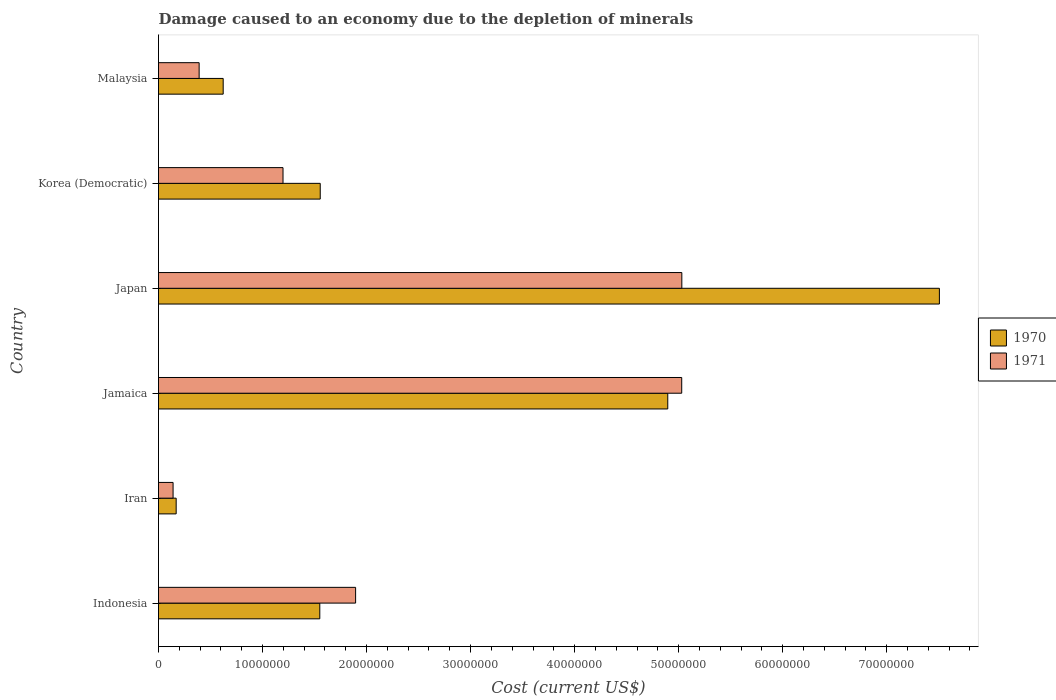How many different coloured bars are there?
Ensure brevity in your answer.  2. How many bars are there on the 4th tick from the top?
Your response must be concise. 2. What is the label of the 3rd group of bars from the top?
Offer a very short reply. Japan. What is the cost of damage caused due to the depletion of minerals in 1970 in Japan?
Your answer should be very brief. 7.51e+07. Across all countries, what is the maximum cost of damage caused due to the depletion of minerals in 1970?
Provide a succinct answer. 7.51e+07. Across all countries, what is the minimum cost of damage caused due to the depletion of minerals in 1970?
Offer a terse response. 1.70e+06. In which country was the cost of damage caused due to the depletion of minerals in 1971 minimum?
Your response must be concise. Iran. What is the total cost of damage caused due to the depletion of minerals in 1970 in the graph?
Your answer should be compact. 1.63e+08. What is the difference between the cost of damage caused due to the depletion of minerals in 1971 in Japan and that in Malaysia?
Provide a short and direct response. 4.64e+07. What is the difference between the cost of damage caused due to the depletion of minerals in 1971 in Iran and the cost of damage caused due to the depletion of minerals in 1970 in Korea (Democratic)?
Your answer should be very brief. -1.41e+07. What is the average cost of damage caused due to the depletion of minerals in 1971 per country?
Give a very brief answer. 2.28e+07. What is the difference between the cost of damage caused due to the depletion of minerals in 1970 and cost of damage caused due to the depletion of minerals in 1971 in Korea (Democratic)?
Give a very brief answer. 3.58e+06. What is the ratio of the cost of damage caused due to the depletion of minerals in 1970 in Japan to that in Korea (Democratic)?
Offer a very short reply. 4.83. Is the cost of damage caused due to the depletion of minerals in 1971 in Iran less than that in Jamaica?
Give a very brief answer. Yes. What is the difference between the highest and the second highest cost of damage caused due to the depletion of minerals in 1970?
Your response must be concise. 2.61e+07. What is the difference between the highest and the lowest cost of damage caused due to the depletion of minerals in 1971?
Offer a very short reply. 4.89e+07. In how many countries, is the cost of damage caused due to the depletion of minerals in 1971 greater than the average cost of damage caused due to the depletion of minerals in 1971 taken over all countries?
Provide a succinct answer. 2. Is the sum of the cost of damage caused due to the depletion of minerals in 1971 in Iran and Malaysia greater than the maximum cost of damage caused due to the depletion of minerals in 1970 across all countries?
Keep it short and to the point. No. What does the 1st bar from the top in Japan represents?
Your response must be concise. 1971. How many bars are there?
Your answer should be very brief. 12. Does the graph contain any zero values?
Make the answer very short. No. Where does the legend appear in the graph?
Offer a very short reply. Center right. How are the legend labels stacked?
Give a very brief answer. Vertical. What is the title of the graph?
Offer a terse response. Damage caused to an economy due to the depletion of minerals. Does "2007" appear as one of the legend labels in the graph?
Provide a short and direct response. No. What is the label or title of the X-axis?
Ensure brevity in your answer.  Cost (current US$). What is the label or title of the Y-axis?
Provide a short and direct response. Country. What is the Cost (current US$) in 1970 in Indonesia?
Your answer should be very brief. 1.55e+07. What is the Cost (current US$) in 1971 in Indonesia?
Offer a very short reply. 1.89e+07. What is the Cost (current US$) in 1970 in Iran?
Make the answer very short. 1.70e+06. What is the Cost (current US$) in 1971 in Iran?
Keep it short and to the point. 1.40e+06. What is the Cost (current US$) in 1970 in Jamaica?
Ensure brevity in your answer.  4.90e+07. What is the Cost (current US$) in 1971 in Jamaica?
Give a very brief answer. 5.03e+07. What is the Cost (current US$) of 1970 in Japan?
Your answer should be compact. 7.51e+07. What is the Cost (current US$) of 1971 in Japan?
Keep it short and to the point. 5.03e+07. What is the Cost (current US$) of 1970 in Korea (Democratic)?
Provide a succinct answer. 1.55e+07. What is the Cost (current US$) of 1971 in Korea (Democratic)?
Your answer should be compact. 1.20e+07. What is the Cost (current US$) of 1970 in Malaysia?
Offer a very short reply. 6.22e+06. What is the Cost (current US$) of 1971 in Malaysia?
Make the answer very short. 3.90e+06. Across all countries, what is the maximum Cost (current US$) in 1970?
Your response must be concise. 7.51e+07. Across all countries, what is the maximum Cost (current US$) of 1971?
Your answer should be compact. 5.03e+07. Across all countries, what is the minimum Cost (current US$) of 1970?
Your response must be concise. 1.70e+06. Across all countries, what is the minimum Cost (current US$) in 1971?
Ensure brevity in your answer.  1.40e+06. What is the total Cost (current US$) in 1970 in the graph?
Offer a very short reply. 1.63e+08. What is the total Cost (current US$) in 1971 in the graph?
Your response must be concise. 1.37e+08. What is the difference between the Cost (current US$) in 1970 in Indonesia and that in Iran?
Ensure brevity in your answer.  1.38e+07. What is the difference between the Cost (current US$) of 1971 in Indonesia and that in Iran?
Your answer should be very brief. 1.75e+07. What is the difference between the Cost (current US$) in 1970 in Indonesia and that in Jamaica?
Ensure brevity in your answer.  -3.35e+07. What is the difference between the Cost (current US$) in 1971 in Indonesia and that in Jamaica?
Provide a succinct answer. -3.14e+07. What is the difference between the Cost (current US$) in 1970 in Indonesia and that in Japan?
Offer a very short reply. -5.96e+07. What is the difference between the Cost (current US$) of 1971 in Indonesia and that in Japan?
Offer a terse response. -3.14e+07. What is the difference between the Cost (current US$) in 1970 in Indonesia and that in Korea (Democratic)?
Offer a terse response. -4.23e+04. What is the difference between the Cost (current US$) in 1971 in Indonesia and that in Korea (Democratic)?
Your answer should be very brief. 6.98e+06. What is the difference between the Cost (current US$) of 1970 in Indonesia and that in Malaysia?
Keep it short and to the point. 9.29e+06. What is the difference between the Cost (current US$) in 1971 in Indonesia and that in Malaysia?
Provide a succinct answer. 1.50e+07. What is the difference between the Cost (current US$) in 1970 in Iran and that in Jamaica?
Keep it short and to the point. -4.73e+07. What is the difference between the Cost (current US$) in 1971 in Iran and that in Jamaica?
Your answer should be very brief. -4.89e+07. What is the difference between the Cost (current US$) in 1970 in Iran and that in Japan?
Your answer should be compact. -7.34e+07. What is the difference between the Cost (current US$) of 1971 in Iran and that in Japan?
Ensure brevity in your answer.  -4.89e+07. What is the difference between the Cost (current US$) of 1970 in Iran and that in Korea (Democratic)?
Offer a very short reply. -1.38e+07. What is the difference between the Cost (current US$) in 1971 in Iran and that in Korea (Democratic)?
Offer a terse response. -1.06e+07. What is the difference between the Cost (current US$) of 1970 in Iran and that in Malaysia?
Offer a terse response. -4.52e+06. What is the difference between the Cost (current US$) of 1971 in Iran and that in Malaysia?
Provide a short and direct response. -2.51e+06. What is the difference between the Cost (current US$) in 1970 in Jamaica and that in Japan?
Your answer should be compact. -2.61e+07. What is the difference between the Cost (current US$) of 1971 in Jamaica and that in Japan?
Offer a very short reply. -1.04e+04. What is the difference between the Cost (current US$) in 1970 in Jamaica and that in Korea (Democratic)?
Your answer should be compact. 3.34e+07. What is the difference between the Cost (current US$) of 1971 in Jamaica and that in Korea (Democratic)?
Make the answer very short. 3.83e+07. What is the difference between the Cost (current US$) of 1970 in Jamaica and that in Malaysia?
Offer a very short reply. 4.27e+07. What is the difference between the Cost (current US$) in 1971 in Jamaica and that in Malaysia?
Give a very brief answer. 4.64e+07. What is the difference between the Cost (current US$) in 1970 in Japan and that in Korea (Democratic)?
Give a very brief answer. 5.95e+07. What is the difference between the Cost (current US$) in 1971 in Japan and that in Korea (Democratic)?
Offer a very short reply. 3.83e+07. What is the difference between the Cost (current US$) in 1970 in Japan and that in Malaysia?
Your answer should be compact. 6.88e+07. What is the difference between the Cost (current US$) in 1971 in Japan and that in Malaysia?
Provide a short and direct response. 4.64e+07. What is the difference between the Cost (current US$) of 1970 in Korea (Democratic) and that in Malaysia?
Provide a succinct answer. 9.33e+06. What is the difference between the Cost (current US$) in 1971 in Korea (Democratic) and that in Malaysia?
Offer a very short reply. 8.06e+06. What is the difference between the Cost (current US$) in 1970 in Indonesia and the Cost (current US$) in 1971 in Iran?
Offer a very short reply. 1.41e+07. What is the difference between the Cost (current US$) in 1970 in Indonesia and the Cost (current US$) in 1971 in Jamaica?
Provide a succinct answer. -3.48e+07. What is the difference between the Cost (current US$) of 1970 in Indonesia and the Cost (current US$) of 1971 in Japan?
Your answer should be compact. -3.48e+07. What is the difference between the Cost (current US$) in 1970 in Indonesia and the Cost (current US$) in 1971 in Korea (Democratic)?
Make the answer very short. 3.54e+06. What is the difference between the Cost (current US$) in 1970 in Indonesia and the Cost (current US$) in 1971 in Malaysia?
Make the answer very short. 1.16e+07. What is the difference between the Cost (current US$) of 1970 in Iran and the Cost (current US$) of 1971 in Jamaica?
Offer a terse response. -4.86e+07. What is the difference between the Cost (current US$) of 1970 in Iran and the Cost (current US$) of 1971 in Japan?
Provide a short and direct response. -4.86e+07. What is the difference between the Cost (current US$) in 1970 in Iran and the Cost (current US$) in 1971 in Korea (Democratic)?
Offer a terse response. -1.03e+07. What is the difference between the Cost (current US$) in 1970 in Iran and the Cost (current US$) in 1971 in Malaysia?
Keep it short and to the point. -2.21e+06. What is the difference between the Cost (current US$) of 1970 in Jamaica and the Cost (current US$) of 1971 in Japan?
Offer a very short reply. -1.35e+06. What is the difference between the Cost (current US$) in 1970 in Jamaica and the Cost (current US$) in 1971 in Korea (Democratic)?
Ensure brevity in your answer.  3.70e+07. What is the difference between the Cost (current US$) of 1970 in Jamaica and the Cost (current US$) of 1971 in Malaysia?
Your answer should be compact. 4.51e+07. What is the difference between the Cost (current US$) of 1970 in Japan and the Cost (current US$) of 1971 in Korea (Democratic)?
Offer a terse response. 6.31e+07. What is the difference between the Cost (current US$) of 1970 in Japan and the Cost (current US$) of 1971 in Malaysia?
Offer a terse response. 7.12e+07. What is the difference between the Cost (current US$) in 1970 in Korea (Democratic) and the Cost (current US$) in 1971 in Malaysia?
Keep it short and to the point. 1.16e+07. What is the average Cost (current US$) in 1970 per country?
Provide a short and direct response. 2.72e+07. What is the average Cost (current US$) in 1971 per country?
Your answer should be compact. 2.28e+07. What is the difference between the Cost (current US$) in 1970 and Cost (current US$) in 1971 in Indonesia?
Give a very brief answer. -3.44e+06. What is the difference between the Cost (current US$) of 1970 and Cost (current US$) of 1971 in Iran?
Give a very brief answer. 2.97e+05. What is the difference between the Cost (current US$) of 1970 and Cost (current US$) of 1971 in Jamaica?
Provide a succinct answer. -1.34e+06. What is the difference between the Cost (current US$) in 1970 and Cost (current US$) in 1971 in Japan?
Offer a very short reply. 2.48e+07. What is the difference between the Cost (current US$) in 1970 and Cost (current US$) in 1971 in Korea (Democratic)?
Your answer should be very brief. 3.58e+06. What is the difference between the Cost (current US$) of 1970 and Cost (current US$) of 1971 in Malaysia?
Make the answer very short. 2.31e+06. What is the ratio of the Cost (current US$) in 1970 in Indonesia to that in Iran?
Your answer should be very brief. 9.14. What is the ratio of the Cost (current US$) in 1971 in Indonesia to that in Iran?
Keep it short and to the point. 13.54. What is the ratio of the Cost (current US$) of 1970 in Indonesia to that in Jamaica?
Give a very brief answer. 0.32. What is the ratio of the Cost (current US$) in 1971 in Indonesia to that in Jamaica?
Provide a short and direct response. 0.38. What is the ratio of the Cost (current US$) in 1970 in Indonesia to that in Japan?
Offer a very short reply. 0.21. What is the ratio of the Cost (current US$) in 1971 in Indonesia to that in Japan?
Give a very brief answer. 0.38. What is the ratio of the Cost (current US$) in 1970 in Indonesia to that in Korea (Democratic)?
Ensure brevity in your answer.  1. What is the ratio of the Cost (current US$) of 1971 in Indonesia to that in Korea (Democratic)?
Offer a terse response. 1.58. What is the ratio of the Cost (current US$) in 1970 in Indonesia to that in Malaysia?
Provide a succinct answer. 2.49. What is the ratio of the Cost (current US$) in 1971 in Indonesia to that in Malaysia?
Offer a very short reply. 4.85. What is the ratio of the Cost (current US$) of 1970 in Iran to that in Jamaica?
Offer a terse response. 0.03. What is the ratio of the Cost (current US$) of 1971 in Iran to that in Jamaica?
Offer a very short reply. 0.03. What is the ratio of the Cost (current US$) in 1970 in Iran to that in Japan?
Your response must be concise. 0.02. What is the ratio of the Cost (current US$) in 1971 in Iran to that in Japan?
Your answer should be very brief. 0.03. What is the ratio of the Cost (current US$) of 1970 in Iran to that in Korea (Democratic)?
Offer a terse response. 0.11. What is the ratio of the Cost (current US$) in 1971 in Iran to that in Korea (Democratic)?
Your answer should be very brief. 0.12. What is the ratio of the Cost (current US$) of 1970 in Iran to that in Malaysia?
Make the answer very short. 0.27. What is the ratio of the Cost (current US$) in 1971 in Iran to that in Malaysia?
Give a very brief answer. 0.36. What is the ratio of the Cost (current US$) of 1970 in Jamaica to that in Japan?
Your answer should be compact. 0.65. What is the ratio of the Cost (current US$) in 1970 in Jamaica to that in Korea (Democratic)?
Offer a very short reply. 3.15. What is the ratio of the Cost (current US$) of 1971 in Jamaica to that in Korea (Democratic)?
Your answer should be very brief. 4.2. What is the ratio of the Cost (current US$) in 1970 in Jamaica to that in Malaysia?
Your answer should be compact. 7.87. What is the ratio of the Cost (current US$) in 1971 in Jamaica to that in Malaysia?
Your response must be concise. 12.88. What is the ratio of the Cost (current US$) of 1970 in Japan to that in Korea (Democratic)?
Provide a succinct answer. 4.83. What is the ratio of the Cost (current US$) in 1971 in Japan to that in Korea (Democratic)?
Offer a very short reply. 4.2. What is the ratio of the Cost (current US$) of 1970 in Japan to that in Malaysia?
Your response must be concise. 12.07. What is the ratio of the Cost (current US$) of 1971 in Japan to that in Malaysia?
Give a very brief answer. 12.88. What is the ratio of the Cost (current US$) of 1970 in Korea (Democratic) to that in Malaysia?
Provide a short and direct response. 2.5. What is the ratio of the Cost (current US$) in 1971 in Korea (Democratic) to that in Malaysia?
Your answer should be very brief. 3.07. What is the difference between the highest and the second highest Cost (current US$) in 1970?
Give a very brief answer. 2.61e+07. What is the difference between the highest and the second highest Cost (current US$) of 1971?
Your answer should be very brief. 1.04e+04. What is the difference between the highest and the lowest Cost (current US$) of 1970?
Offer a very short reply. 7.34e+07. What is the difference between the highest and the lowest Cost (current US$) in 1971?
Provide a short and direct response. 4.89e+07. 